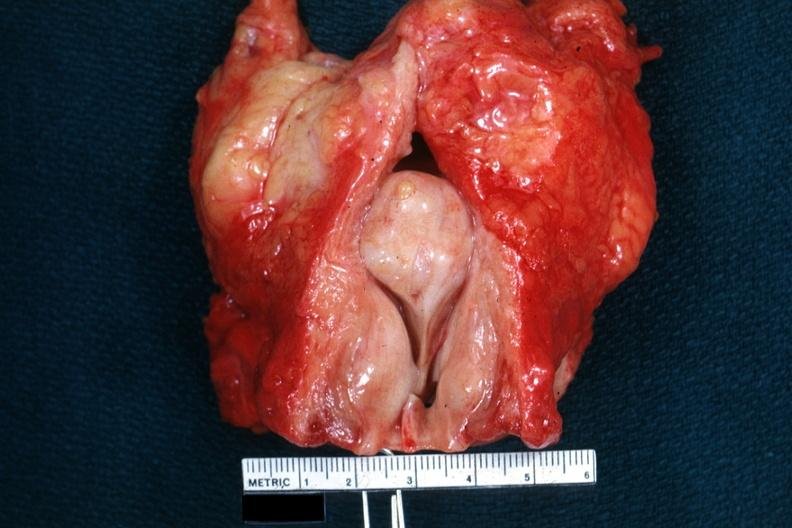what is present?
Answer the question using a single word or phrase. Hyperplasia 